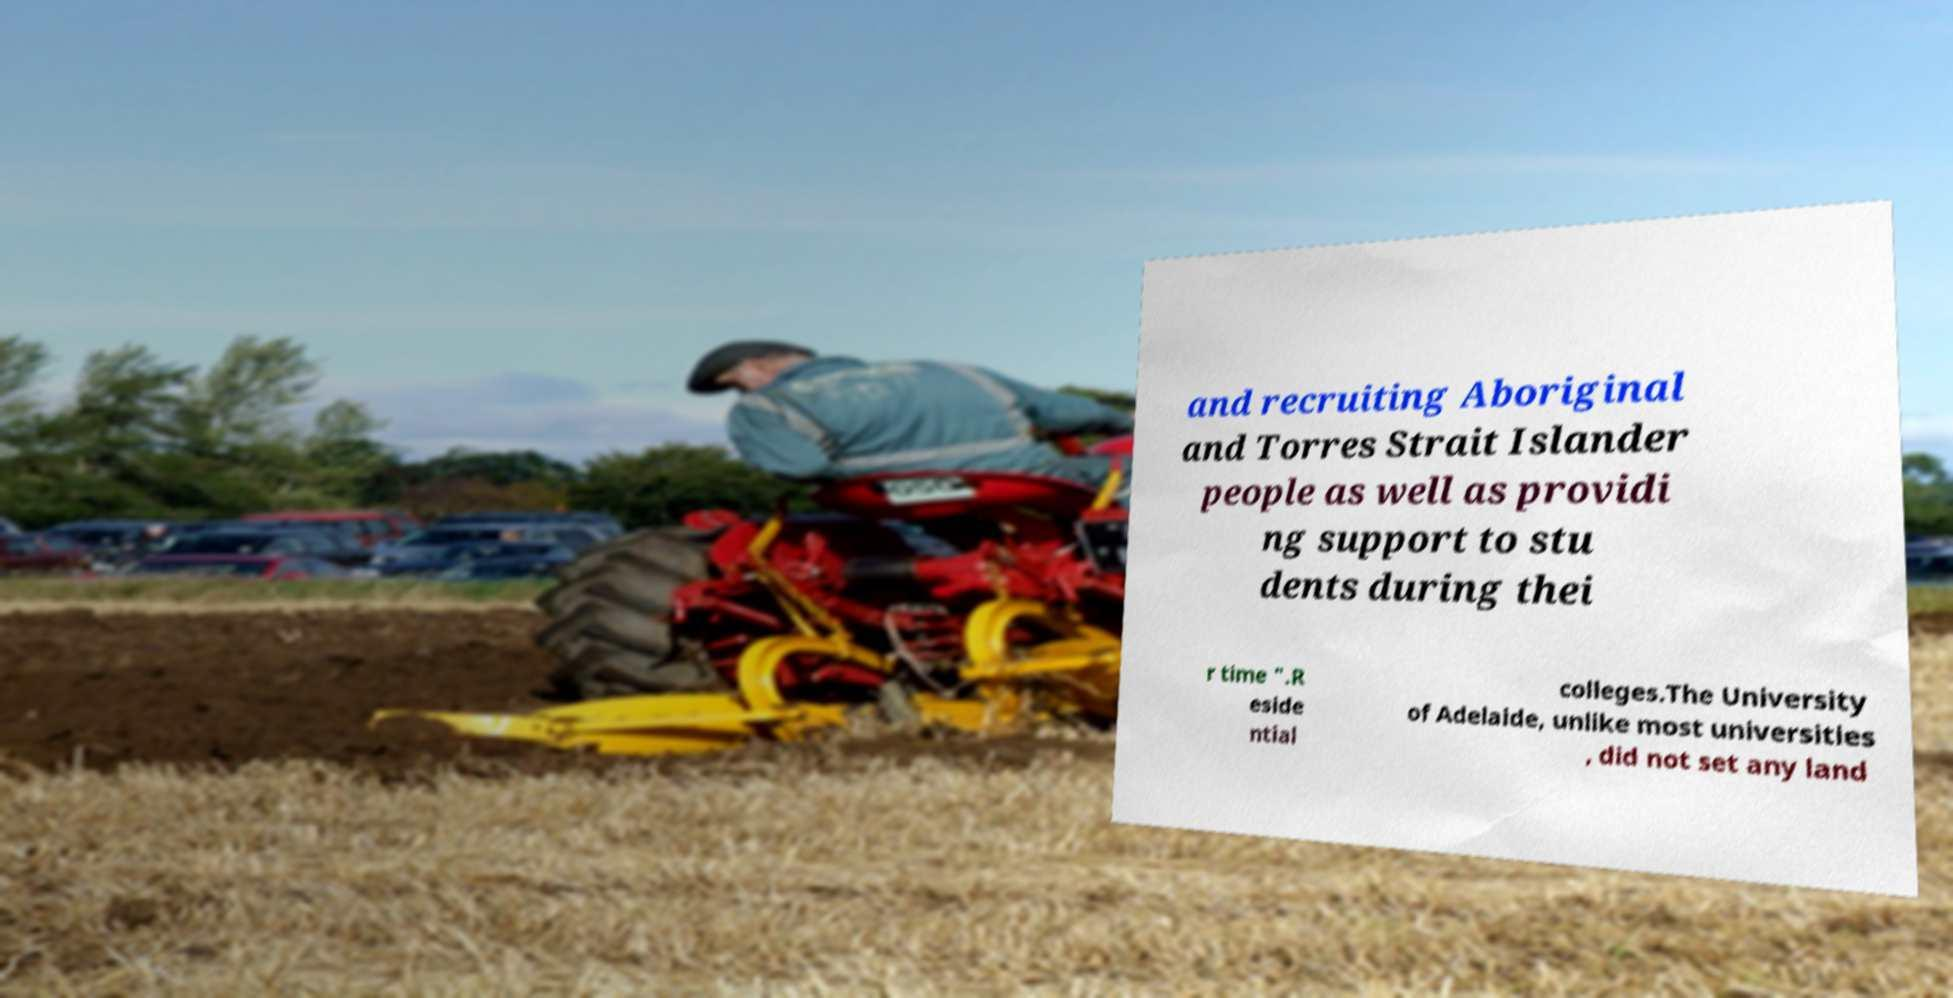Can you accurately transcribe the text from the provided image for me? and recruiting Aboriginal and Torres Strait Islander people as well as providi ng support to stu dents during thei r time ".R eside ntial colleges.The University of Adelaide, unlike most universities , did not set any land 